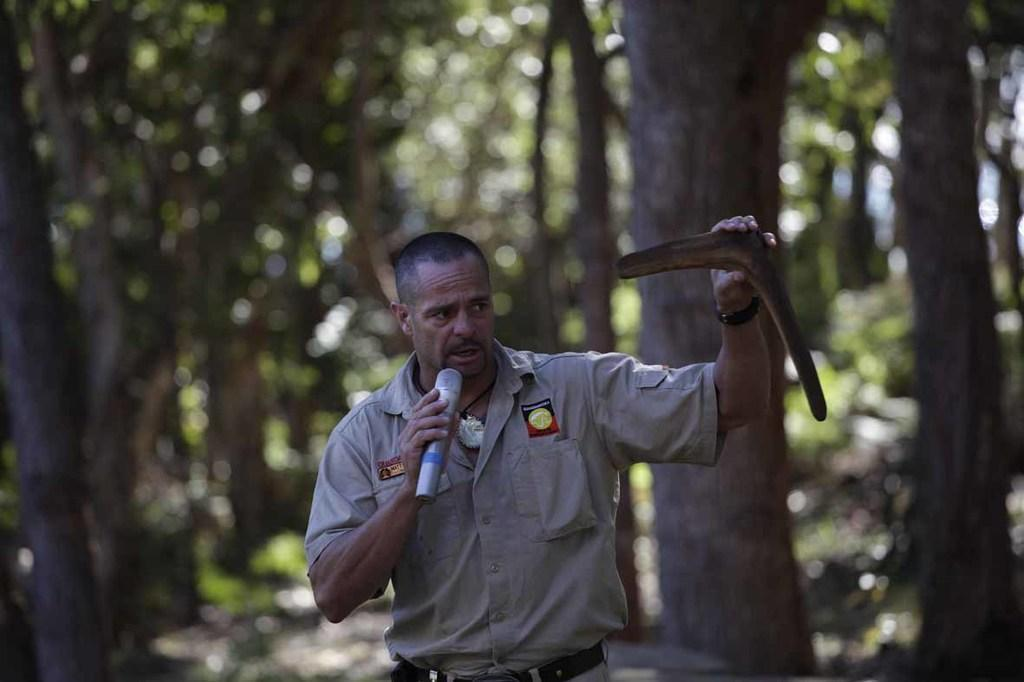What is the main subject of the image? There is a person in the image. What is the person wearing? The person is wearing clothes. What objects is the person holding? The person is holding a mic and a boomerang. Can you describe the background of the image? The background of the image is blurred. What type of mask is the person wearing in the image? There is no mask visible in the image; the person is wearing clothes. What kind of vessel is being used by the person in the image? There is no vessel present in the image; the person is holding a mic and a boomerang. 